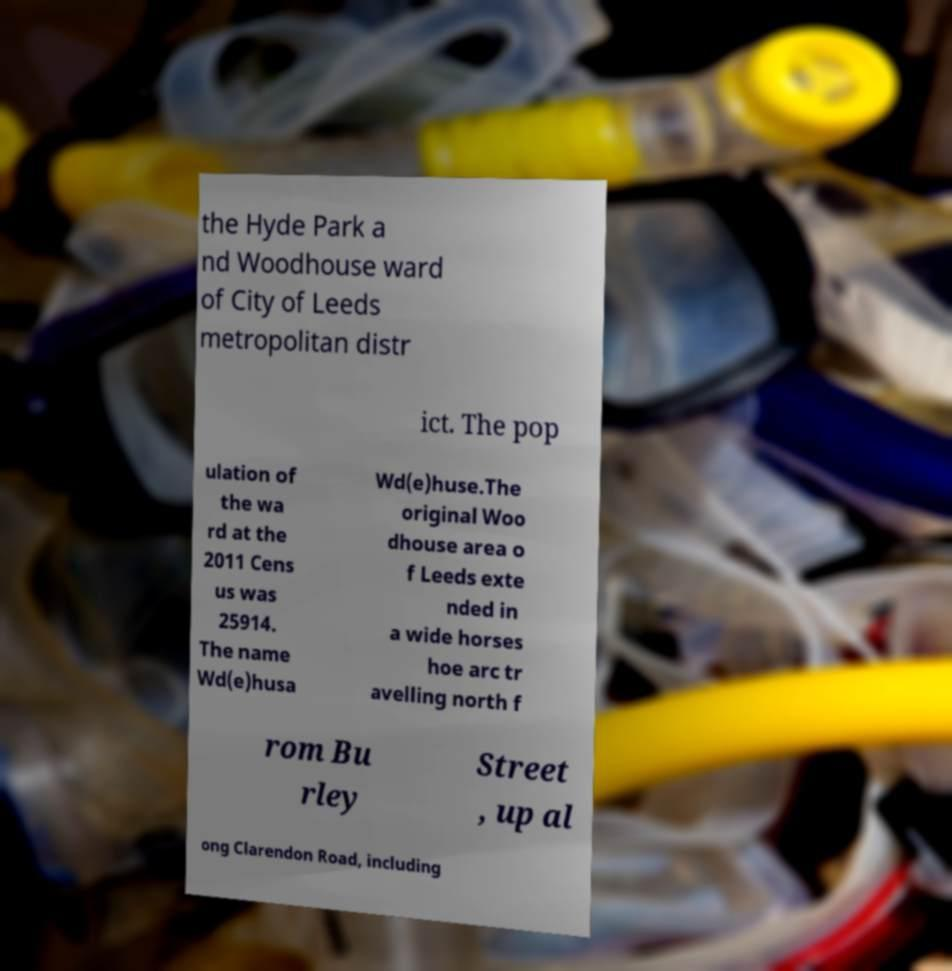What messages or text are displayed in this image? I need them in a readable, typed format. the Hyde Park a nd Woodhouse ward of City of Leeds metropolitan distr ict. The pop ulation of the wa rd at the 2011 Cens us was 25914. The name Wd(e)husa Wd(e)huse.The original Woo dhouse area o f Leeds exte nded in a wide horses hoe arc tr avelling north f rom Bu rley Street , up al ong Clarendon Road, including 